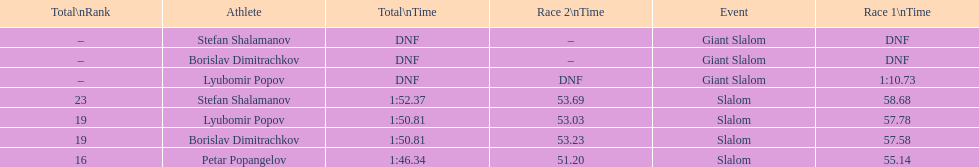What is the rank number of stefan shalamanov in the slalom event 23. 